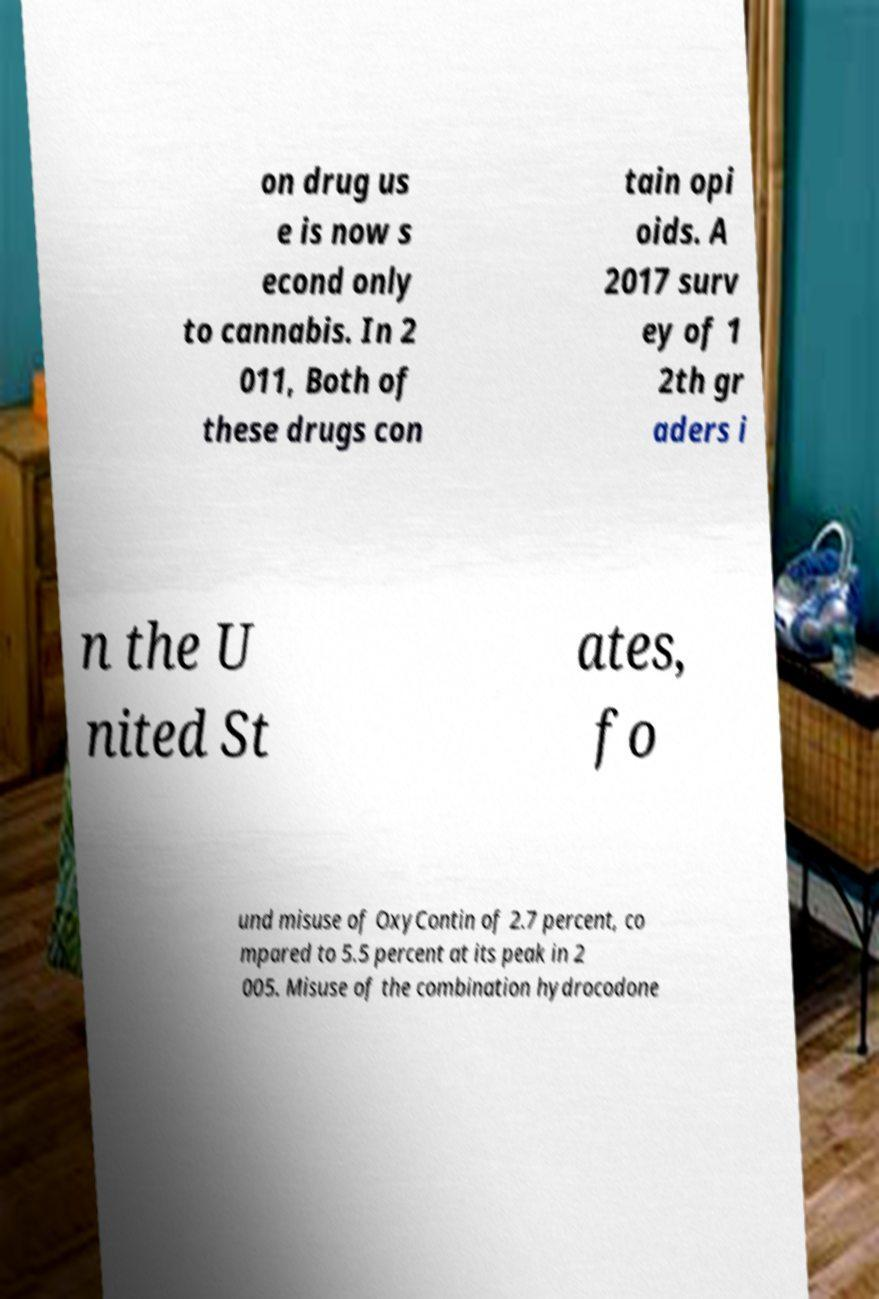Could you assist in decoding the text presented in this image and type it out clearly? on drug us e is now s econd only to cannabis. In 2 011, Both of these drugs con tain opi oids. A 2017 surv ey of 1 2th gr aders i n the U nited St ates, fo und misuse of OxyContin of 2.7 percent, co mpared to 5.5 percent at its peak in 2 005. Misuse of the combination hydrocodone 